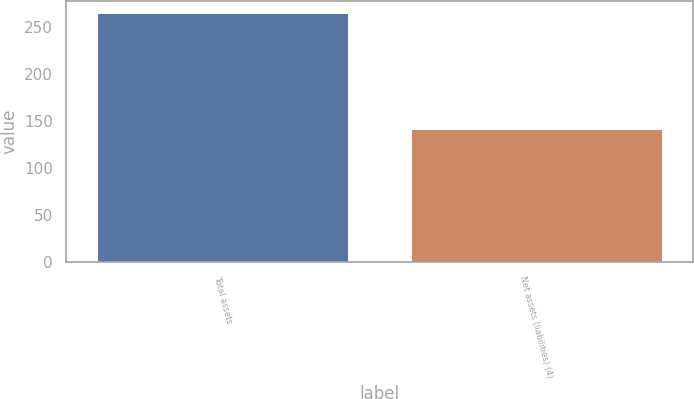<chart> <loc_0><loc_0><loc_500><loc_500><bar_chart><fcel>Total assets<fcel>Net assets (liabilities) (4)<nl><fcel>264<fcel>141<nl></chart> 